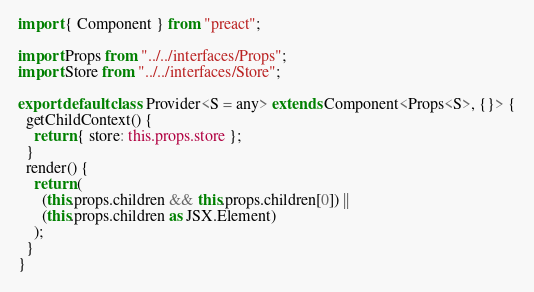<code> <loc_0><loc_0><loc_500><loc_500><_TypeScript_>import { Component } from "preact";

import Props from "../../interfaces/Props";
import Store from "../../interfaces/Store";

export default class Provider<S = any> extends Component<Props<S>, {}> {
  getChildContext() {
    return { store: this.props.store };
  }
  render() {
    return (
      (this.props.children && this.props.children[0]) ||
      (this.props.children as JSX.Element)
    );
  }
}
</code> 